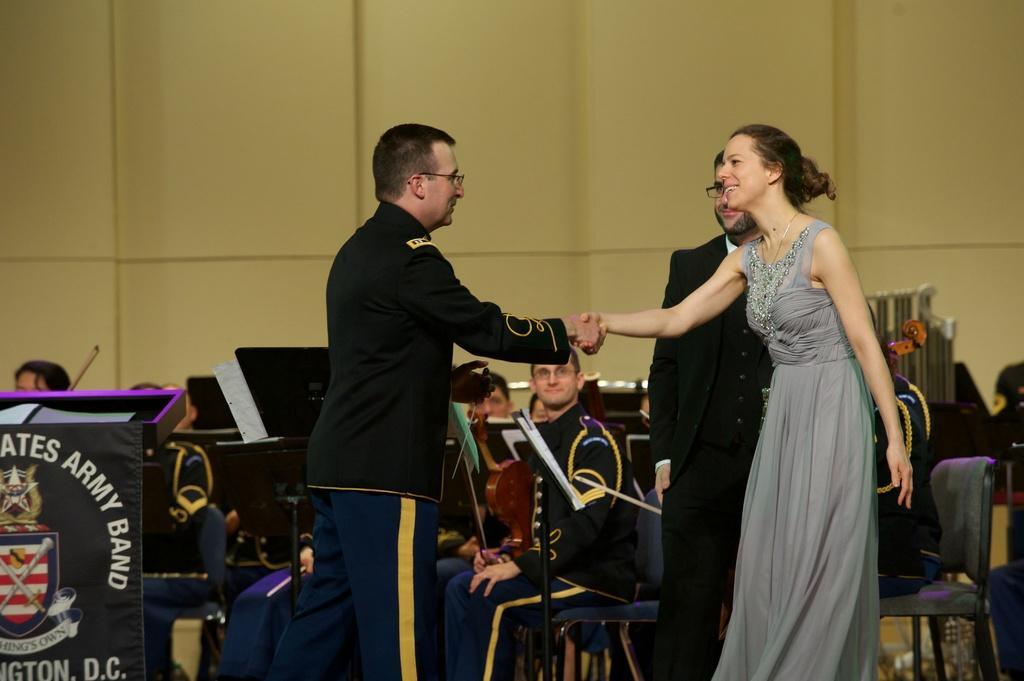Could you give a brief overview of what you see in this image? In this image I can see two people are shaking-hands. Back I can see few people are sitting on chairs. I can see books,stand and podium. The wall is in cream color. 